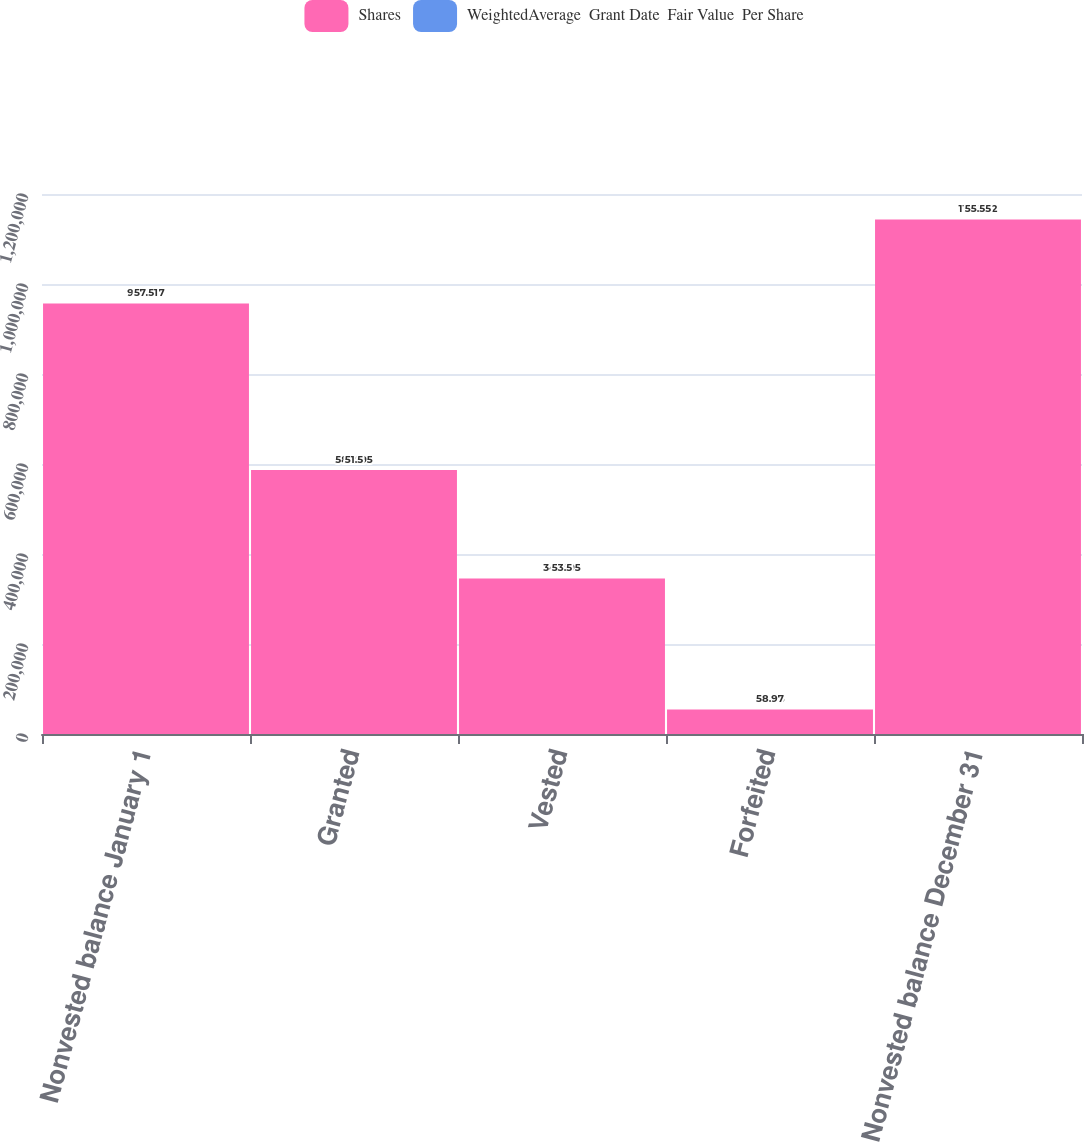Convert chart to OTSL. <chart><loc_0><loc_0><loc_500><loc_500><stacked_bar_chart><ecel><fcel>Nonvested balance January 1<fcel>Granted<fcel>Vested<fcel>Forfeited<fcel>Nonvested balance December 31<nl><fcel>Shares<fcel>956697<fcel>586695<fcel>345695<fcel>54415<fcel>1.14328e+06<nl><fcel>WeightedAverage  Grant Date  Fair Value  Per Share<fcel>57.51<fcel>51.5<fcel>53.5<fcel>58.97<fcel>55.55<nl></chart> 